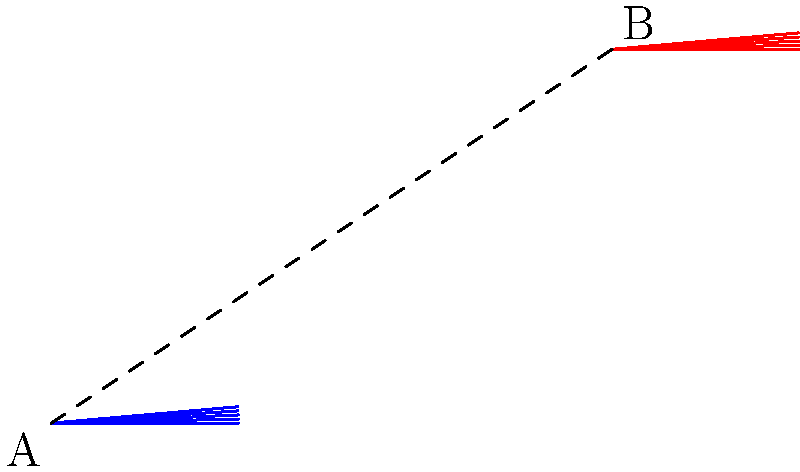In a study of stained glass window designs from various religious buildings, you encounter a five-pointed star shape that has been translated. If point A $(0,0)$ is the center of the original star and point B $(3,2)$ is the center of the translated star, what is the translation vector that moves the star from A to B? To find the translation vector, we need to follow these steps:

1. Identify the coordinates of the initial and final positions:
   - Initial position (point A): $(0,0)$
   - Final position (point B): $(3,2)$

2. Calculate the displacement in the x-direction:
   $\Delta x = x_{\text{final}} - x_{\text{initial}} = 3 - 0 = 3$

3. Calculate the displacement in the y-direction:
   $\Delta y = y_{\text{final}} - y_{\text{initial}} = 2 - 0 = 2$

4. Express the translation vector as an ordered pair:
   Translation vector = $(\Delta x, \Delta y) = (3,2)$

This vector represents the movement of 3 units in the positive x-direction and 2 units in the positive y-direction, which transforms the original star centered at A to the new position centered at B.
Answer: $(3,2)$ 